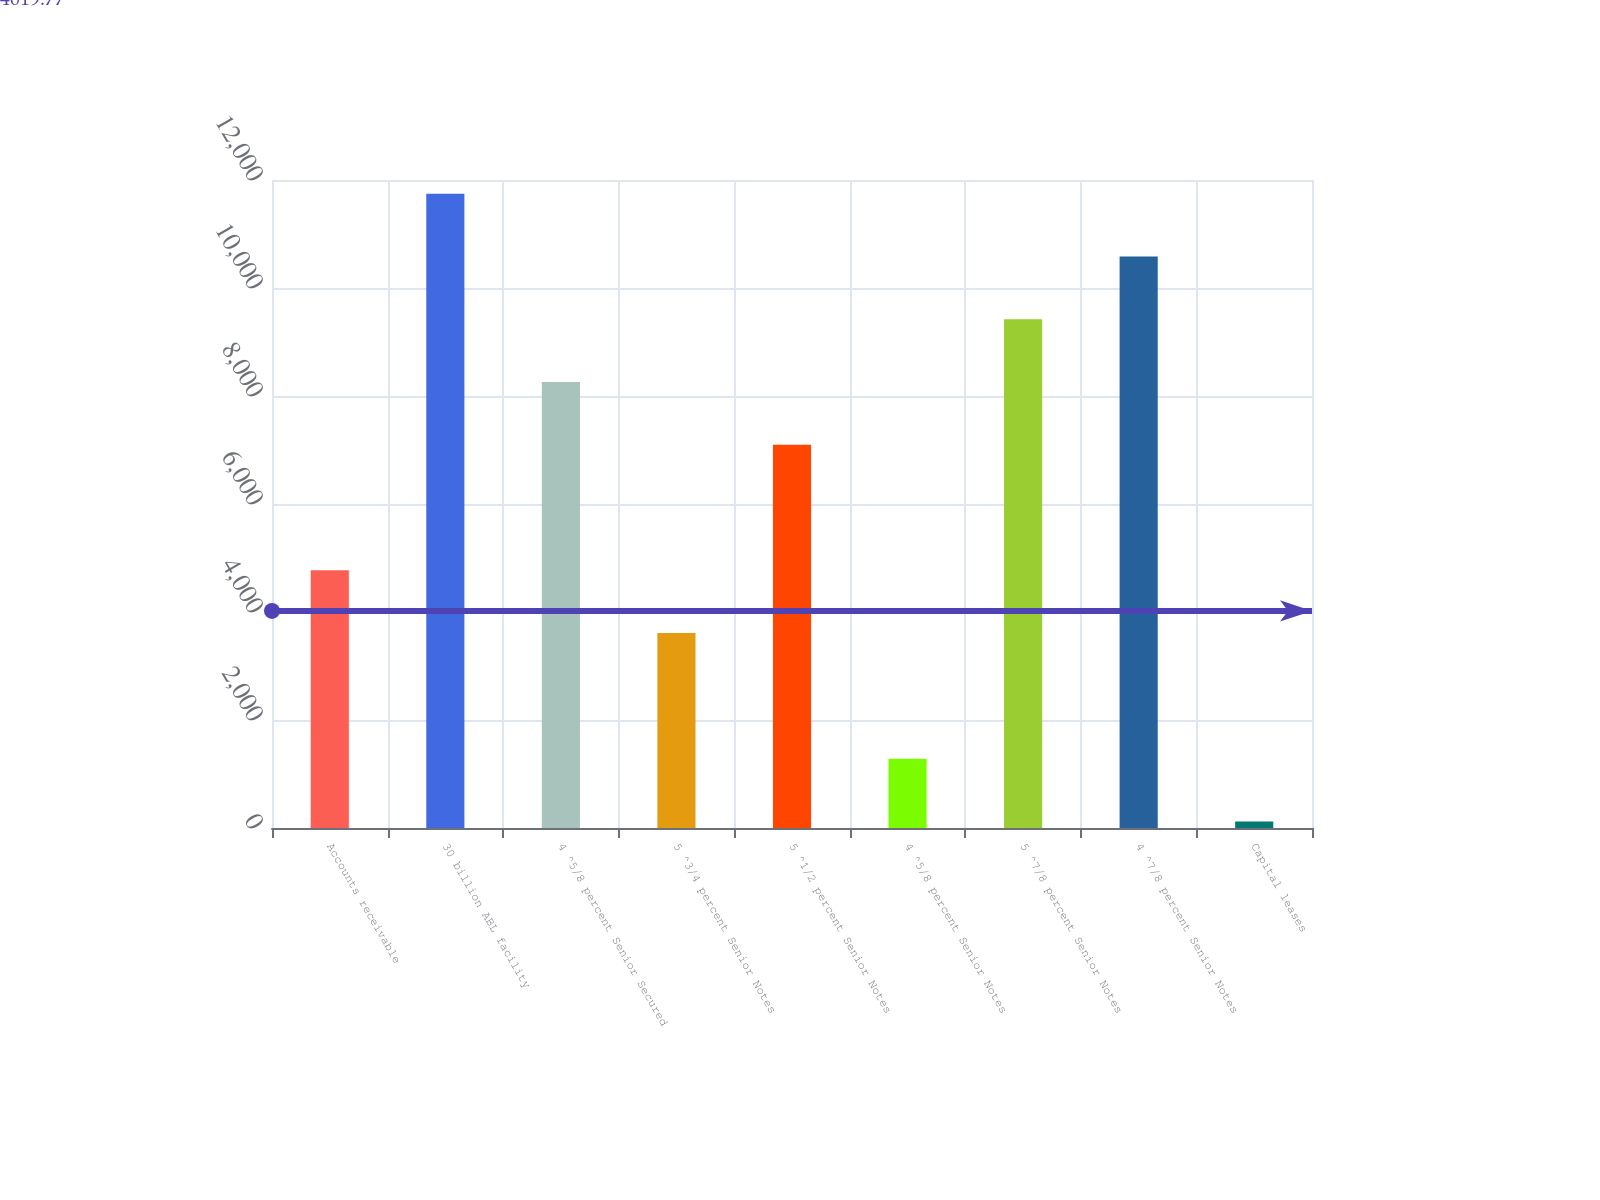<chart> <loc_0><loc_0><loc_500><loc_500><bar_chart><fcel>Accounts receivable<fcel>30 billion ABL facility<fcel>4 ^5/8 percent Senior Secured<fcel>5 ^3/4 percent Senior Notes<fcel>5 ^1/2 percent Senior Notes<fcel>4 ^5/8 percent Senior Notes<fcel>5 ^7/8 percent Senior Notes<fcel>4 ^7/8 percent Senior Notes<fcel>Capital leases<nl><fcel>4772<fcel>11747<fcel>8259.5<fcel>3609.5<fcel>7097<fcel>1284.5<fcel>9422<fcel>10584.5<fcel>122<nl></chart> 